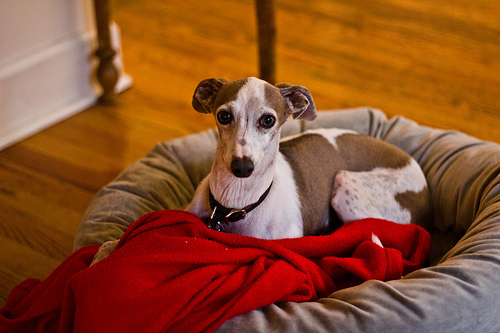<image>
Is the dog in the dog bed? Yes. The dog is contained within or inside the dog bed, showing a containment relationship. Is there a baseboard behind the cushion? Yes. From this viewpoint, the baseboard is positioned behind the cushion, with the cushion partially or fully occluding the baseboard. 